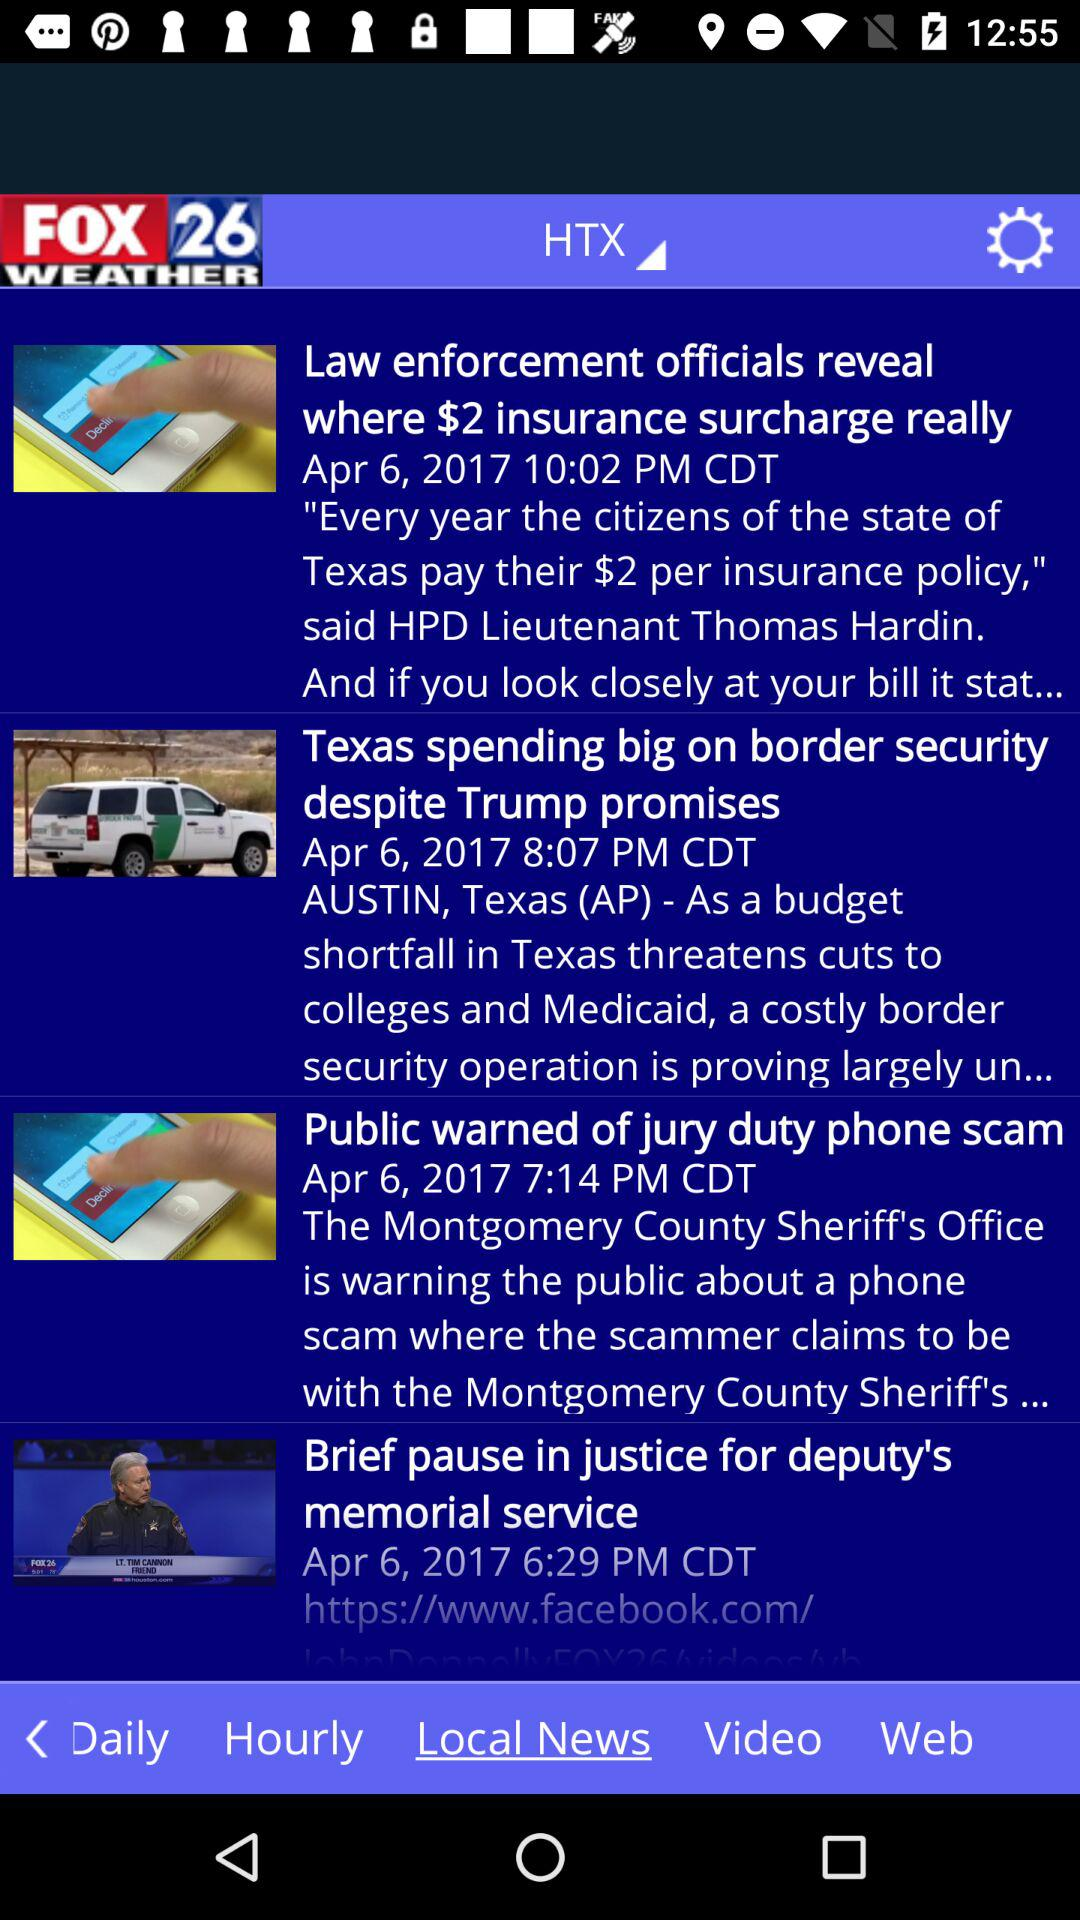How many news stories are there on the main page?
Answer the question using a single word or phrase. 4 